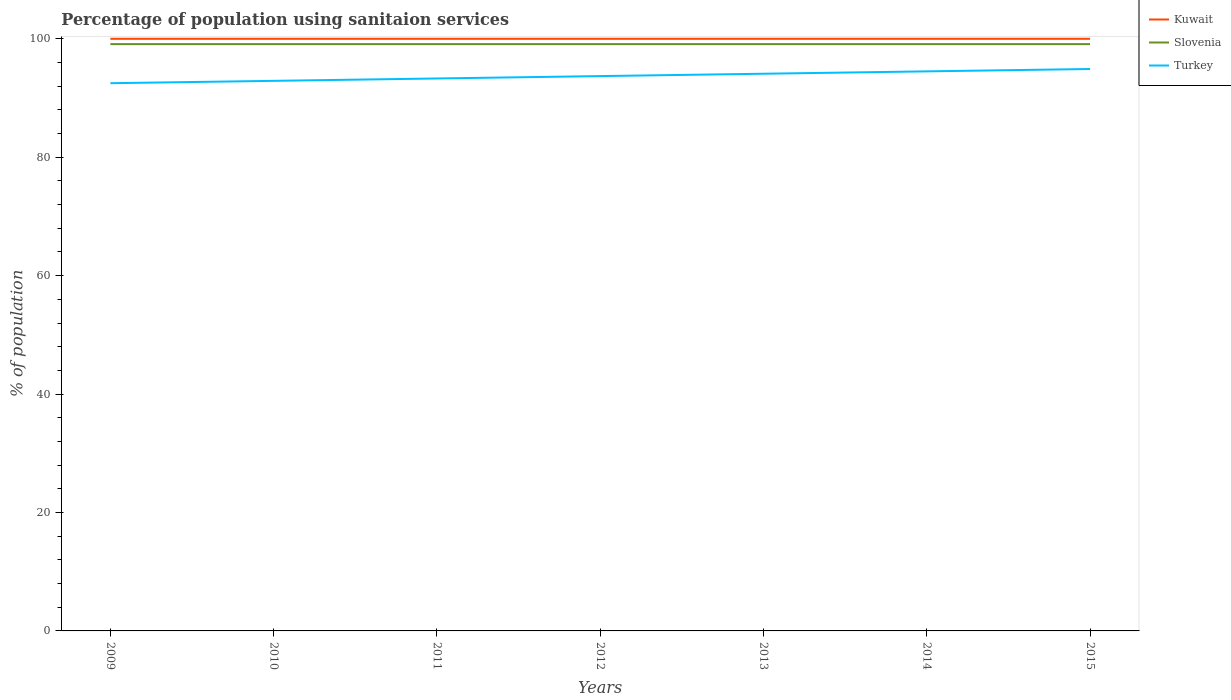Does the line corresponding to Turkey intersect with the line corresponding to Slovenia?
Offer a terse response. No. Is the number of lines equal to the number of legend labels?
Give a very brief answer. Yes. Across all years, what is the maximum percentage of population using sanitaion services in Turkey?
Provide a succinct answer. 92.5. What is the total percentage of population using sanitaion services in Turkey in the graph?
Offer a very short reply. -0.4. What is the difference between the highest and the lowest percentage of population using sanitaion services in Kuwait?
Provide a succinct answer. 0. How many years are there in the graph?
Offer a terse response. 7. Does the graph contain any zero values?
Your answer should be compact. No. Does the graph contain grids?
Offer a terse response. No. How are the legend labels stacked?
Keep it short and to the point. Vertical. What is the title of the graph?
Keep it short and to the point. Percentage of population using sanitaion services. What is the label or title of the X-axis?
Your answer should be compact. Years. What is the label or title of the Y-axis?
Your response must be concise. % of population. What is the % of population of Kuwait in 2009?
Ensure brevity in your answer.  100. What is the % of population in Slovenia in 2009?
Make the answer very short. 99.1. What is the % of population of Turkey in 2009?
Keep it short and to the point. 92.5. What is the % of population in Slovenia in 2010?
Offer a terse response. 99.1. What is the % of population of Turkey in 2010?
Make the answer very short. 92.9. What is the % of population in Slovenia in 2011?
Offer a terse response. 99.1. What is the % of population in Turkey in 2011?
Give a very brief answer. 93.3. What is the % of population in Kuwait in 2012?
Provide a short and direct response. 100. What is the % of population in Slovenia in 2012?
Your answer should be very brief. 99.1. What is the % of population of Turkey in 2012?
Provide a short and direct response. 93.7. What is the % of population in Kuwait in 2013?
Ensure brevity in your answer.  100. What is the % of population of Slovenia in 2013?
Provide a succinct answer. 99.1. What is the % of population of Turkey in 2013?
Your answer should be compact. 94.1. What is the % of population in Slovenia in 2014?
Your answer should be compact. 99.1. What is the % of population of Turkey in 2014?
Ensure brevity in your answer.  94.5. What is the % of population in Kuwait in 2015?
Provide a succinct answer. 100. What is the % of population in Slovenia in 2015?
Offer a very short reply. 99.1. What is the % of population of Turkey in 2015?
Provide a succinct answer. 94.9. Across all years, what is the maximum % of population of Kuwait?
Keep it short and to the point. 100. Across all years, what is the maximum % of population of Slovenia?
Provide a short and direct response. 99.1. Across all years, what is the maximum % of population of Turkey?
Your answer should be very brief. 94.9. Across all years, what is the minimum % of population of Kuwait?
Make the answer very short. 100. Across all years, what is the minimum % of population of Slovenia?
Your answer should be compact. 99.1. Across all years, what is the minimum % of population in Turkey?
Provide a succinct answer. 92.5. What is the total % of population of Kuwait in the graph?
Give a very brief answer. 700. What is the total % of population in Slovenia in the graph?
Your answer should be compact. 693.7. What is the total % of population of Turkey in the graph?
Your answer should be compact. 655.9. What is the difference between the % of population of Kuwait in 2009 and that in 2010?
Make the answer very short. 0. What is the difference between the % of population of Slovenia in 2009 and that in 2010?
Your answer should be compact. 0. What is the difference between the % of population of Slovenia in 2009 and that in 2012?
Offer a very short reply. 0. What is the difference between the % of population in Kuwait in 2009 and that in 2013?
Keep it short and to the point. 0. What is the difference between the % of population of Turkey in 2009 and that in 2013?
Offer a terse response. -1.6. What is the difference between the % of population in Kuwait in 2009 and that in 2014?
Keep it short and to the point. 0. What is the difference between the % of population in Slovenia in 2009 and that in 2014?
Give a very brief answer. 0. What is the difference between the % of population of Kuwait in 2009 and that in 2015?
Provide a succinct answer. 0. What is the difference between the % of population in Turkey in 2009 and that in 2015?
Your response must be concise. -2.4. What is the difference between the % of population of Kuwait in 2010 and that in 2011?
Your answer should be very brief. 0. What is the difference between the % of population of Slovenia in 2010 and that in 2012?
Ensure brevity in your answer.  0. What is the difference between the % of population in Turkey in 2010 and that in 2012?
Give a very brief answer. -0.8. What is the difference between the % of population of Slovenia in 2010 and that in 2013?
Keep it short and to the point. 0. What is the difference between the % of population in Turkey in 2010 and that in 2013?
Your answer should be compact. -1.2. What is the difference between the % of population of Slovenia in 2010 and that in 2014?
Offer a terse response. 0. What is the difference between the % of population in Slovenia in 2010 and that in 2015?
Provide a short and direct response. 0. What is the difference between the % of population of Turkey in 2010 and that in 2015?
Make the answer very short. -2. What is the difference between the % of population in Slovenia in 2011 and that in 2012?
Your answer should be compact. 0. What is the difference between the % of population in Kuwait in 2011 and that in 2013?
Make the answer very short. 0. What is the difference between the % of population of Slovenia in 2011 and that in 2013?
Provide a succinct answer. 0. What is the difference between the % of population of Kuwait in 2011 and that in 2014?
Your response must be concise. 0. What is the difference between the % of population in Kuwait in 2011 and that in 2015?
Offer a terse response. 0. What is the difference between the % of population in Turkey in 2011 and that in 2015?
Make the answer very short. -1.6. What is the difference between the % of population of Kuwait in 2012 and that in 2013?
Provide a short and direct response. 0. What is the difference between the % of population in Turkey in 2012 and that in 2013?
Your answer should be compact. -0.4. What is the difference between the % of population of Kuwait in 2012 and that in 2014?
Your answer should be very brief. 0. What is the difference between the % of population of Slovenia in 2012 and that in 2015?
Give a very brief answer. 0. What is the difference between the % of population of Turkey in 2012 and that in 2015?
Keep it short and to the point. -1.2. What is the difference between the % of population of Slovenia in 2013 and that in 2014?
Keep it short and to the point. 0. What is the difference between the % of population of Kuwait in 2013 and that in 2015?
Keep it short and to the point. 0. What is the difference between the % of population in Slovenia in 2013 and that in 2015?
Provide a short and direct response. 0. What is the difference between the % of population of Turkey in 2013 and that in 2015?
Provide a succinct answer. -0.8. What is the difference between the % of population of Slovenia in 2014 and that in 2015?
Keep it short and to the point. 0. What is the difference between the % of population in Kuwait in 2009 and the % of population in Slovenia in 2010?
Offer a very short reply. 0.9. What is the difference between the % of population of Kuwait in 2009 and the % of population of Slovenia in 2011?
Give a very brief answer. 0.9. What is the difference between the % of population in Kuwait in 2009 and the % of population in Slovenia in 2012?
Offer a very short reply. 0.9. What is the difference between the % of population in Slovenia in 2009 and the % of population in Turkey in 2012?
Provide a succinct answer. 5.4. What is the difference between the % of population of Kuwait in 2009 and the % of population of Turkey in 2013?
Give a very brief answer. 5.9. What is the difference between the % of population in Slovenia in 2009 and the % of population in Turkey in 2014?
Your answer should be very brief. 4.6. What is the difference between the % of population of Kuwait in 2009 and the % of population of Slovenia in 2015?
Offer a terse response. 0.9. What is the difference between the % of population in Kuwait in 2010 and the % of population in Slovenia in 2011?
Make the answer very short. 0.9. What is the difference between the % of population in Kuwait in 2010 and the % of population in Turkey in 2011?
Offer a terse response. 6.7. What is the difference between the % of population of Kuwait in 2010 and the % of population of Slovenia in 2012?
Provide a succinct answer. 0.9. What is the difference between the % of population of Kuwait in 2010 and the % of population of Turkey in 2012?
Give a very brief answer. 6.3. What is the difference between the % of population in Slovenia in 2010 and the % of population in Turkey in 2012?
Keep it short and to the point. 5.4. What is the difference between the % of population in Slovenia in 2010 and the % of population in Turkey in 2013?
Your answer should be compact. 5. What is the difference between the % of population in Kuwait in 2010 and the % of population in Slovenia in 2014?
Offer a terse response. 0.9. What is the difference between the % of population in Kuwait in 2010 and the % of population in Turkey in 2014?
Offer a terse response. 5.5. What is the difference between the % of population in Kuwait in 2010 and the % of population in Slovenia in 2015?
Offer a terse response. 0.9. What is the difference between the % of population of Kuwait in 2010 and the % of population of Turkey in 2015?
Ensure brevity in your answer.  5.1. What is the difference between the % of population of Kuwait in 2011 and the % of population of Turkey in 2014?
Provide a short and direct response. 5.5. What is the difference between the % of population in Slovenia in 2011 and the % of population in Turkey in 2014?
Keep it short and to the point. 4.6. What is the difference between the % of population in Kuwait in 2011 and the % of population in Slovenia in 2015?
Keep it short and to the point. 0.9. What is the difference between the % of population of Kuwait in 2011 and the % of population of Turkey in 2015?
Give a very brief answer. 5.1. What is the difference between the % of population of Slovenia in 2012 and the % of population of Turkey in 2013?
Provide a short and direct response. 5. What is the difference between the % of population of Kuwait in 2012 and the % of population of Turkey in 2014?
Your answer should be compact. 5.5. What is the difference between the % of population in Slovenia in 2012 and the % of population in Turkey in 2014?
Ensure brevity in your answer.  4.6. What is the difference between the % of population in Kuwait in 2012 and the % of population in Slovenia in 2015?
Give a very brief answer. 0.9. What is the difference between the % of population of Kuwait in 2012 and the % of population of Turkey in 2015?
Offer a terse response. 5.1. What is the difference between the % of population of Slovenia in 2013 and the % of population of Turkey in 2014?
Your answer should be very brief. 4.6. What is the difference between the % of population of Slovenia in 2013 and the % of population of Turkey in 2015?
Make the answer very short. 4.2. What is the difference between the % of population in Kuwait in 2014 and the % of population in Turkey in 2015?
Provide a succinct answer. 5.1. What is the difference between the % of population of Slovenia in 2014 and the % of population of Turkey in 2015?
Your response must be concise. 4.2. What is the average % of population in Kuwait per year?
Keep it short and to the point. 100. What is the average % of population of Slovenia per year?
Keep it short and to the point. 99.1. What is the average % of population in Turkey per year?
Keep it short and to the point. 93.7. In the year 2009, what is the difference between the % of population in Slovenia and % of population in Turkey?
Provide a short and direct response. 6.6. In the year 2010, what is the difference between the % of population in Kuwait and % of population in Slovenia?
Keep it short and to the point. 0.9. In the year 2010, what is the difference between the % of population in Slovenia and % of population in Turkey?
Your response must be concise. 6.2. In the year 2011, what is the difference between the % of population of Kuwait and % of population of Turkey?
Provide a succinct answer. 6.7. In the year 2012, what is the difference between the % of population of Kuwait and % of population of Turkey?
Offer a terse response. 6.3. In the year 2013, what is the difference between the % of population in Kuwait and % of population in Slovenia?
Provide a succinct answer. 0.9. What is the ratio of the % of population in Kuwait in 2009 to that in 2010?
Offer a very short reply. 1. What is the ratio of the % of population of Turkey in 2009 to that in 2010?
Keep it short and to the point. 1. What is the ratio of the % of population of Kuwait in 2009 to that in 2011?
Your response must be concise. 1. What is the ratio of the % of population of Turkey in 2009 to that in 2011?
Your response must be concise. 0.99. What is the ratio of the % of population of Kuwait in 2009 to that in 2012?
Keep it short and to the point. 1. What is the ratio of the % of population of Turkey in 2009 to that in 2012?
Provide a short and direct response. 0.99. What is the ratio of the % of population in Turkey in 2009 to that in 2013?
Give a very brief answer. 0.98. What is the ratio of the % of population in Slovenia in 2009 to that in 2014?
Provide a short and direct response. 1. What is the ratio of the % of population of Turkey in 2009 to that in 2014?
Offer a terse response. 0.98. What is the ratio of the % of population in Turkey in 2009 to that in 2015?
Make the answer very short. 0.97. What is the ratio of the % of population of Kuwait in 2010 to that in 2011?
Give a very brief answer. 1. What is the ratio of the % of population of Turkey in 2010 to that in 2011?
Your response must be concise. 1. What is the ratio of the % of population of Kuwait in 2010 to that in 2013?
Provide a succinct answer. 1. What is the ratio of the % of population of Slovenia in 2010 to that in 2013?
Your answer should be compact. 1. What is the ratio of the % of population of Turkey in 2010 to that in 2013?
Keep it short and to the point. 0.99. What is the ratio of the % of population in Slovenia in 2010 to that in 2014?
Make the answer very short. 1. What is the ratio of the % of population of Turkey in 2010 to that in 2014?
Give a very brief answer. 0.98. What is the ratio of the % of population in Kuwait in 2010 to that in 2015?
Keep it short and to the point. 1. What is the ratio of the % of population of Turkey in 2010 to that in 2015?
Give a very brief answer. 0.98. What is the ratio of the % of population in Kuwait in 2011 to that in 2012?
Your answer should be compact. 1. What is the ratio of the % of population in Kuwait in 2011 to that in 2013?
Your answer should be very brief. 1. What is the ratio of the % of population of Slovenia in 2011 to that in 2013?
Your response must be concise. 1. What is the ratio of the % of population of Turkey in 2011 to that in 2014?
Offer a terse response. 0.99. What is the ratio of the % of population in Kuwait in 2011 to that in 2015?
Your response must be concise. 1. What is the ratio of the % of population in Turkey in 2011 to that in 2015?
Your answer should be compact. 0.98. What is the ratio of the % of population in Slovenia in 2012 to that in 2013?
Ensure brevity in your answer.  1. What is the ratio of the % of population of Turkey in 2012 to that in 2013?
Offer a terse response. 1. What is the ratio of the % of population in Kuwait in 2012 to that in 2014?
Your response must be concise. 1. What is the ratio of the % of population in Turkey in 2012 to that in 2014?
Provide a succinct answer. 0.99. What is the ratio of the % of population in Turkey in 2012 to that in 2015?
Offer a very short reply. 0.99. What is the ratio of the % of population of Slovenia in 2013 to that in 2014?
Offer a terse response. 1. What is the ratio of the % of population of Turkey in 2013 to that in 2014?
Your response must be concise. 1. What is the ratio of the % of population of Kuwait in 2013 to that in 2015?
Keep it short and to the point. 1. What is the ratio of the % of population of Turkey in 2013 to that in 2015?
Provide a succinct answer. 0.99. What is the ratio of the % of population of Slovenia in 2014 to that in 2015?
Your answer should be compact. 1. What is the difference between the highest and the second highest % of population of Slovenia?
Your answer should be very brief. 0. What is the difference between the highest and the second highest % of population in Turkey?
Provide a succinct answer. 0.4. What is the difference between the highest and the lowest % of population in Turkey?
Provide a short and direct response. 2.4. 